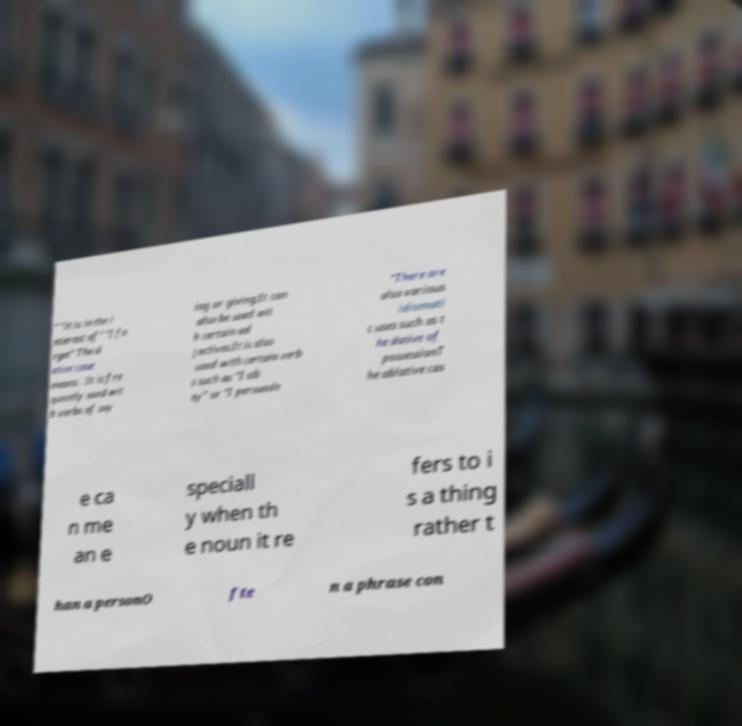Can you read and provide the text displayed in the image?This photo seems to have some interesting text. Can you extract and type it out for me? " "it is in the i nterest of" "I fo rget" The d ative case means . It is fre quently used wit h verbs of say ing or giving:It can also be used wit h certain ad jectives:It is also used with certain verb s such as "I ob ey" or "I persuade "There are also various idiomati c uses such as t he dative of possessionT he ablative cas e ca n me an e speciall y when th e noun it re fers to i s a thing rather t han a personO fte n a phrase con 